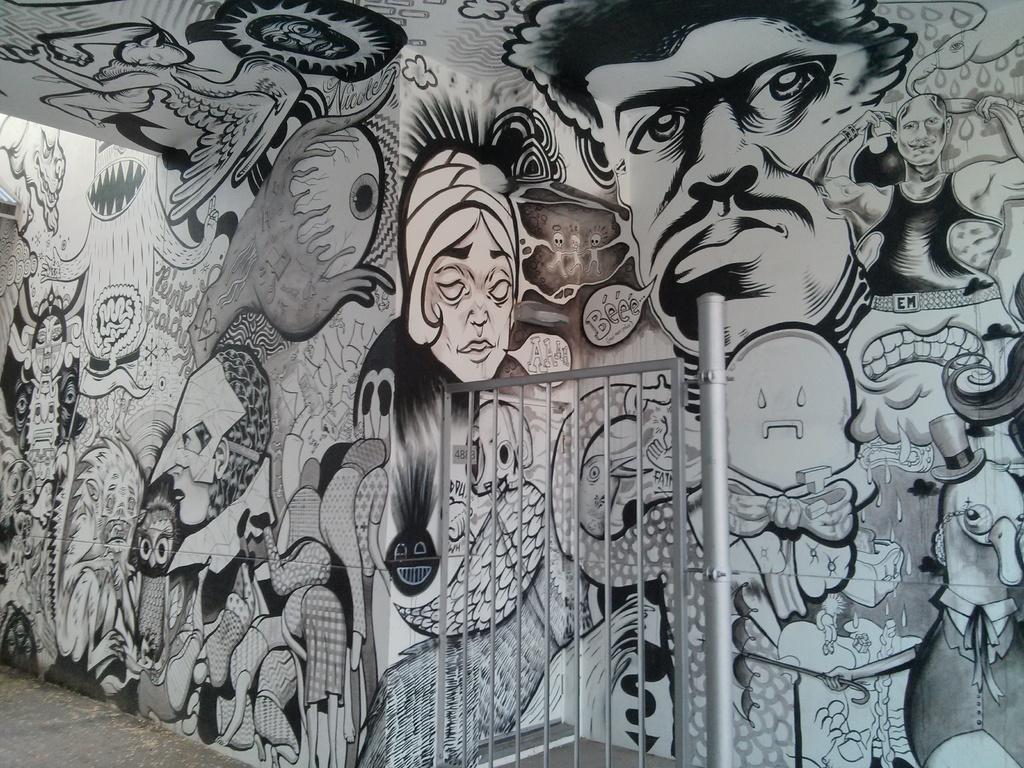In one or two sentences, can you explain what this image depicts? In this picture we can see a wall, there is a painting on the wall. 